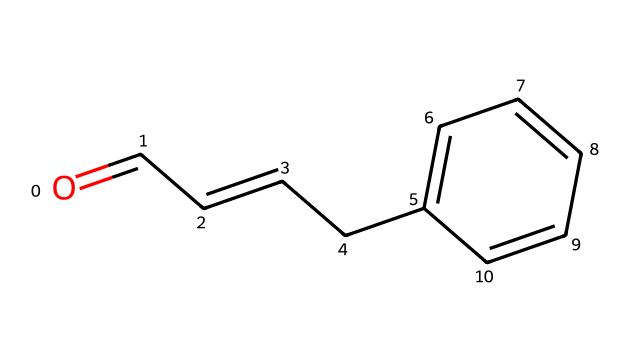What is the molecular formula of this compound? The SMILES representation indicates a compound with specific arrangements of carbon and oxygen atoms. By analyzing the structure, we can count the atoms: there are 10 carbon atoms and 2 oxygen atoms. The molecular formula can thus be written as C10H10O.
Answer: C10H10O How many double bonds are present in the structure? In the given SMILES notation, we note the presence of "=" which indicates double bonds. There are two instances of "=" in the chemical structure, meaning there are two double bonds.
Answer: 2 What type of functional group is present in this chemical? The presence of the carbonyl group (C=O) is identified in the structure. This functional group is indicated by the placement of oxygen adjacent to carbon, suggesting it's an aldehyde.
Answer: aldehyde Is this compound likely to be soluble in water? Non-electrolytes, like this compound, typically do not dissociate in water and lack polar functionalities capable of strong interactions with water. Given its non-polar structure, it is therefore not likely to be soluble in water.
Answer: No What is the hybridization of the carbon atoms in the benzene ring? The carbon atoms in the benzene ring are involved in sp2 hybridization, as they form part of a planar structure with alternating single and double bonds. This is a characteristic of aromatic compounds.
Answer: sp2 What is the primary type of bonding in this compound? The bonding in this molecule is largely covalent, characterized by the sharing of electron pairs between atoms. The structure features numerous carbon-carbon and carbon-hydrogen bonds indicating a covalent nature.
Answer: covalent 